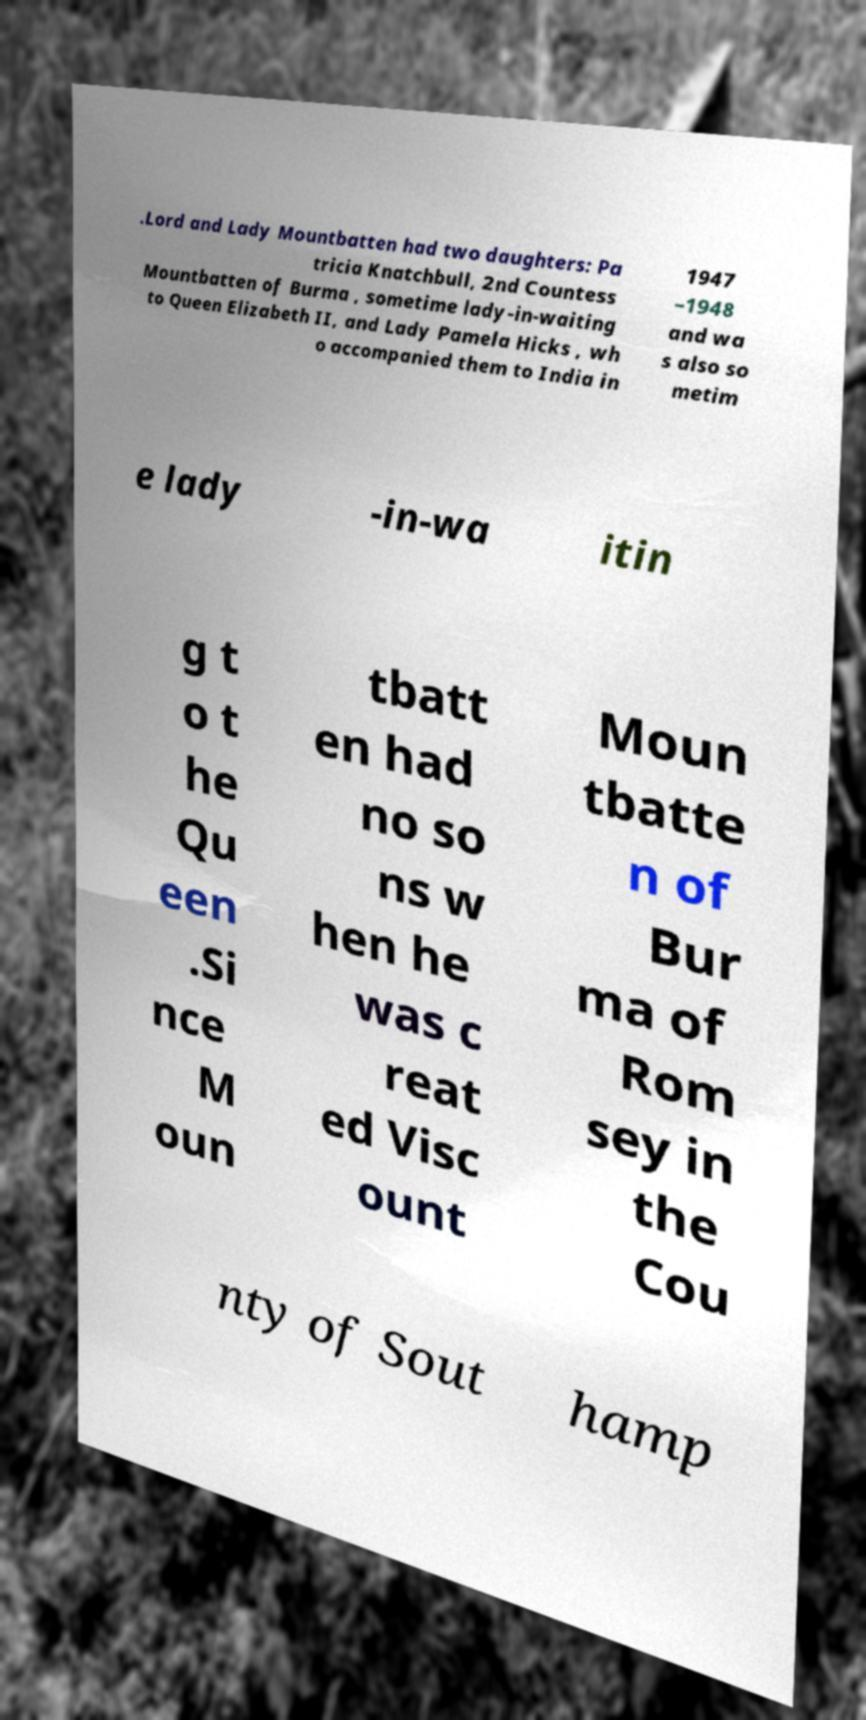There's text embedded in this image that I need extracted. Can you transcribe it verbatim? .Lord and Lady Mountbatten had two daughters: Pa tricia Knatchbull, 2nd Countess Mountbatten of Burma , sometime lady-in-waiting to Queen Elizabeth II, and Lady Pamela Hicks , wh o accompanied them to India in 1947 –1948 and wa s also so metim e lady -in-wa itin g t o t he Qu een .Si nce M oun tbatt en had no so ns w hen he was c reat ed Visc ount Moun tbatte n of Bur ma of Rom sey in the Cou nty of Sout hamp 